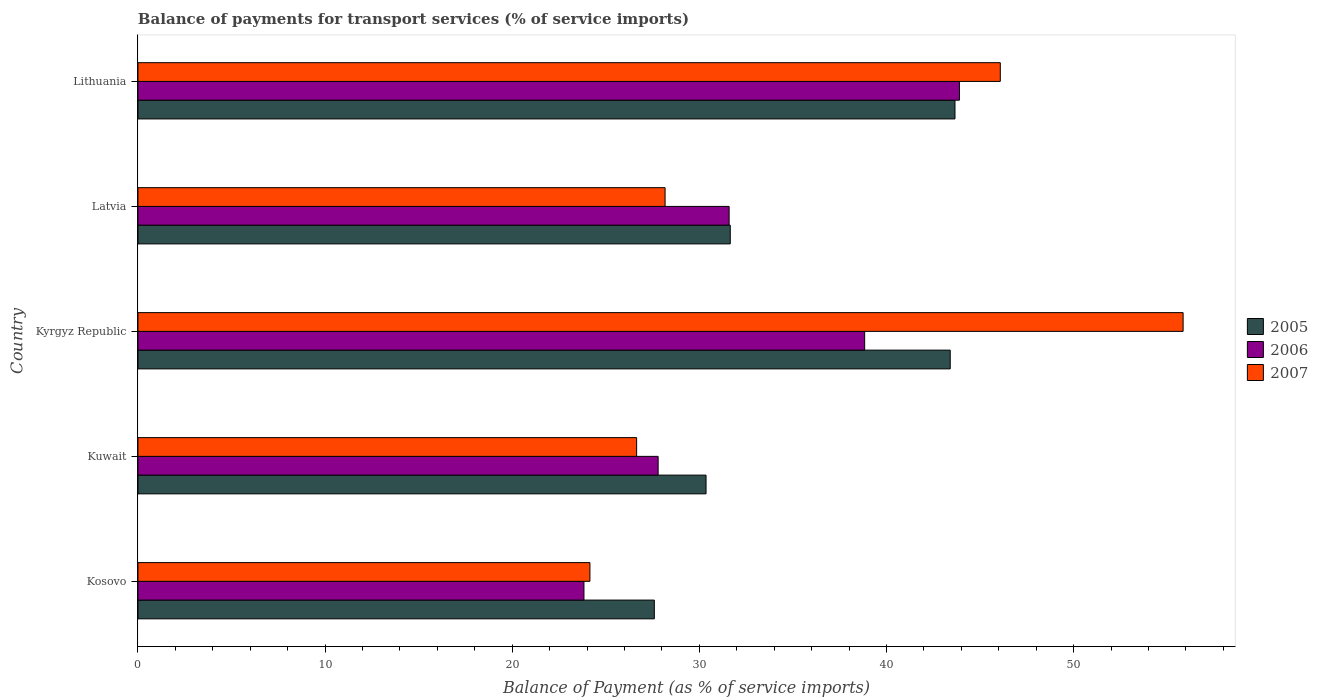How many different coloured bars are there?
Give a very brief answer. 3. How many groups of bars are there?
Keep it short and to the point. 5. How many bars are there on the 5th tick from the top?
Keep it short and to the point. 3. What is the label of the 5th group of bars from the top?
Ensure brevity in your answer.  Kosovo. What is the balance of payments for transport services in 2006 in Lithuania?
Offer a terse response. 43.9. Across all countries, what is the maximum balance of payments for transport services in 2005?
Your answer should be very brief. 43.66. Across all countries, what is the minimum balance of payments for transport services in 2007?
Your answer should be compact. 24.15. In which country was the balance of payments for transport services in 2007 maximum?
Make the answer very short. Kyrgyz Republic. In which country was the balance of payments for transport services in 2006 minimum?
Make the answer very short. Kosovo. What is the total balance of payments for transport services in 2007 in the graph?
Ensure brevity in your answer.  180.9. What is the difference between the balance of payments for transport services in 2005 in Kyrgyz Republic and that in Latvia?
Your answer should be very brief. 11.75. What is the difference between the balance of payments for transport services in 2006 in Kuwait and the balance of payments for transport services in 2007 in Lithuania?
Your answer should be very brief. -18.28. What is the average balance of payments for transport services in 2007 per country?
Provide a succinct answer. 36.18. What is the difference between the balance of payments for transport services in 2005 and balance of payments for transport services in 2006 in Kyrgyz Republic?
Your answer should be compact. 4.57. What is the ratio of the balance of payments for transport services in 2007 in Latvia to that in Lithuania?
Your answer should be compact. 0.61. Is the difference between the balance of payments for transport services in 2005 in Kuwait and Kyrgyz Republic greater than the difference between the balance of payments for transport services in 2006 in Kuwait and Kyrgyz Republic?
Ensure brevity in your answer.  No. What is the difference between the highest and the second highest balance of payments for transport services in 2005?
Provide a short and direct response. 0.25. What is the difference between the highest and the lowest balance of payments for transport services in 2007?
Ensure brevity in your answer.  31.7. What does the 1st bar from the top in Latvia represents?
Make the answer very short. 2007. How many bars are there?
Offer a very short reply. 15. Are all the bars in the graph horizontal?
Offer a terse response. Yes. Are the values on the major ticks of X-axis written in scientific E-notation?
Offer a very short reply. No. Does the graph contain grids?
Offer a terse response. No. Where does the legend appear in the graph?
Your answer should be very brief. Center right. How are the legend labels stacked?
Offer a very short reply. Vertical. What is the title of the graph?
Your answer should be very brief. Balance of payments for transport services (% of service imports). What is the label or title of the X-axis?
Give a very brief answer. Balance of Payment (as % of service imports). What is the Balance of Payment (as % of service imports) in 2005 in Kosovo?
Your answer should be compact. 27.59. What is the Balance of Payment (as % of service imports) of 2006 in Kosovo?
Ensure brevity in your answer.  23.83. What is the Balance of Payment (as % of service imports) of 2007 in Kosovo?
Offer a very short reply. 24.15. What is the Balance of Payment (as % of service imports) in 2005 in Kuwait?
Offer a very short reply. 30.36. What is the Balance of Payment (as % of service imports) in 2006 in Kuwait?
Your answer should be compact. 27.8. What is the Balance of Payment (as % of service imports) of 2007 in Kuwait?
Your answer should be very brief. 26.65. What is the Balance of Payment (as % of service imports) of 2005 in Kyrgyz Republic?
Provide a short and direct response. 43.41. What is the Balance of Payment (as % of service imports) of 2006 in Kyrgyz Republic?
Offer a very short reply. 38.83. What is the Balance of Payment (as % of service imports) in 2007 in Kyrgyz Republic?
Offer a very short reply. 55.85. What is the Balance of Payment (as % of service imports) of 2005 in Latvia?
Offer a very short reply. 31.65. What is the Balance of Payment (as % of service imports) of 2006 in Latvia?
Your response must be concise. 31.59. What is the Balance of Payment (as % of service imports) in 2007 in Latvia?
Your answer should be very brief. 28.17. What is the Balance of Payment (as % of service imports) in 2005 in Lithuania?
Make the answer very short. 43.66. What is the Balance of Payment (as % of service imports) in 2006 in Lithuania?
Your answer should be very brief. 43.9. What is the Balance of Payment (as % of service imports) of 2007 in Lithuania?
Offer a very short reply. 46.08. Across all countries, what is the maximum Balance of Payment (as % of service imports) in 2005?
Ensure brevity in your answer.  43.66. Across all countries, what is the maximum Balance of Payment (as % of service imports) in 2006?
Give a very brief answer. 43.9. Across all countries, what is the maximum Balance of Payment (as % of service imports) of 2007?
Your answer should be very brief. 55.85. Across all countries, what is the minimum Balance of Payment (as % of service imports) of 2005?
Make the answer very short. 27.59. Across all countries, what is the minimum Balance of Payment (as % of service imports) in 2006?
Offer a very short reply. 23.83. Across all countries, what is the minimum Balance of Payment (as % of service imports) in 2007?
Offer a terse response. 24.15. What is the total Balance of Payment (as % of service imports) of 2005 in the graph?
Provide a short and direct response. 176.67. What is the total Balance of Payment (as % of service imports) of 2006 in the graph?
Ensure brevity in your answer.  165.95. What is the total Balance of Payment (as % of service imports) of 2007 in the graph?
Your response must be concise. 180.9. What is the difference between the Balance of Payment (as % of service imports) in 2005 in Kosovo and that in Kuwait?
Make the answer very short. -2.76. What is the difference between the Balance of Payment (as % of service imports) in 2006 in Kosovo and that in Kuwait?
Ensure brevity in your answer.  -3.96. What is the difference between the Balance of Payment (as % of service imports) in 2007 in Kosovo and that in Kuwait?
Your answer should be compact. -2.5. What is the difference between the Balance of Payment (as % of service imports) in 2005 in Kosovo and that in Kyrgyz Republic?
Your answer should be very brief. -15.81. What is the difference between the Balance of Payment (as % of service imports) of 2006 in Kosovo and that in Kyrgyz Republic?
Offer a terse response. -15. What is the difference between the Balance of Payment (as % of service imports) in 2007 in Kosovo and that in Kyrgyz Republic?
Your answer should be very brief. -31.7. What is the difference between the Balance of Payment (as % of service imports) in 2005 in Kosovo and that in Latvia?
Give a very brief answer. -4.06. What is the difference between the Balance of Payment (as % of service imports) in 2006 in Kosovo and that in Latvia?
Your response must be concise. -7.76. What is the difference between the Balance of Payment (as % of service imports) in 2007 in Kosovo and that in Latvia?
Your answer should be very brief. -4.02. What is the difference between the Balance of Payment (as % of service imports) of 2005 in Kosovo and that in Lithuania?
Give a very brief answer. -16.07. What is the difference between the Balance of Payment (as % of service imports) of 2006 in Kosovo and that in Lithuania?
Offer a terse response. -20.07. What is the difference between the Balance of Payment (as % of service imports) in 2007 in Kosovo and that in Lithuania?
Give a very brief answer. -21.93. What is the difference between the Balance of Payment (as % of service imports) in 2005 in Kuwait and that in Kyrgyz Republic?
Your answer should be very brief. -13.05. What is the difference between the Balance of Payment (as % of service imports) of 2006 in Kuwait and that in Kyrgyz Republic?
Your answer should be compact. -11.04. What is the difference between the Balance of Payment (as % of service imports) in 2007 in Kuwait and that in Kyrgyz Republic?
Your answer should be compact. -29.2. What is the difference between the Balance of Payment (as % of service imports) of 2005 in Kuwait and that in Latvia?
Ensure brevity in your answer.  -1.29. What is the difference between the Balance of Payment (as % of service imports) of 2006 in Kuwait and that in Latvia?
Ensure brevity in your answer.  -3.79. What is the difference between the Balance of Payment (as % of service imports) of 2007 in Kuwait and that in Latvia?
Your answer should be compact. -1.52. What is the difference between the Balance of Payment (as % of service imports) in 2005 in Kuwait and that in Lithuania?
Your answer should be very brief. -13.3. What is the difference between the Balance of Payment (as % of service imports) in 2006 in Kuwait and that in Lithuania?
Ensure brevity in your answer.  -16.1. What is the difference between the Balance of Payment (as % of service imports) of 2007 in Kuwait and that in Lithuania?
Make the answer very short. -19.43. What is the difference between the Balance of Payment (as % of service imports) in 2005 in Kyrgyz Republic and that in Latvia?
Keep it short and to the point. 11.75. What is the difference between the Balance of Payment (as % of service imports) of 2006 in Kyrgyz Republic and that in Latvia?
Offer a very short reply. 7.24. What is the difference between the Balance of Payment (as % of service imports) in 2007 in Kyrgyz Republic and that in Latvia?
Make the answer very short. 27.68. What is the difference between the Balance of Payment (as % of service imports) of 2005 in Kyrgyz Republic and that in Lithuania?
Make the answer very short. -0.25. What is the difference between the Balance of Payment (as % of service imports) of 2006 in Kyrgyz Republic and that in Lithuania?
Offer a very short reply. -5.07. What is the difference between the Balance of Payment (as % of service imports) in 2007 in Kyrgyz Republic and that in Lithuania?
Your response must be concise. 9.77. What is the difference between the Balance of Payment (as % of service imports) of 2005 in Latvia and that in Lithuania?
Your answer should be very brief. -12.01. What is the difference between the Balance of Payment (as % of service imports) of 2006 in Latvia and that in Lithuania?
Provide a succinct answer. -12.31. What is the difference between the Balance of Payment (as % of service imports) in 2007 in Latvia and that in Lithuania?
Keep it short and to the point. -17.91. What is the difference between the Balance of Payment (as % of service imports) of 2005 in Kosovo and the Balance of Payment (as % of service imports) of 2006 in Kuwait?
Offer a very short reply. -0.2. What is the difference between the Balance of Payment (as % of service imports) in 2005 in Kosovo and the Balance of Payment (as % of service imports) in 2007 in Kuwait?
Your response must be concise. 0.95. What is the difference between the Balance of Payment (as % of service imports) of 2006 in Kosovo and the Balance of Payment (as % of service imports) of 2007 in Kuwait?
Your response must be concise. -2.81. What is the difference between the Balance of Payment (as % of service imports) in 2005 in Kosovo and the Balance of Payment (as % of service imports) in 2006 in Kyrgyz Republic?
Your answer should be compact. -11.24. What is the difference between the Balance of Payment (as % of service imports) of 2005 in Kosovo and the Balance of Payment (as % of service imports) of 2007 in Kyrgyz Republic?
Ensure brevity in your answer.  -28.26. What is the difference between the Balance of Payment (as % of service imports) of 2006 in Kosovo and the Balance of Payment (as % of service imports) of 2007 in Kyrgyz Republic?
Offer a terse response. -32.02. What is the difference between the Balance of Payment (as % of service imports) in 2005 in Kosovo and the Balance of Payment (as % of service imports) in 2006 in Latvia?
Your answer should be very brief. -4. What is the difference between the Balance of Payment (as % of service imports) of 2005 in Kosovo and the Balance of Payment (as % of service imports) of 2007 in Latvia?
Offer a terse response. -0.57. What is the difference between the Balance of Payment (as % of service imports) in 2006 in Kosovo and the Balance of Payment (as % of service imports) in 2007 in Latvia?
Make the answer very short. -4.33. What is the difference between the Balance of Payment (as % of service imports) of 2005 in Kosovo and the Balance of Payment (as % of service imports) of 2006 in Lithuania?
Provide a succinct answer. -16.3. What is the difference between the Balance of Payment (as % of service imports) of 2005 in Kosovo and the Balance of Payment (as % of service imports) of 2007 in Lithuania?
Offer a very short reply. -18.49. What is the difference between the Balance of Payment (as % of service imports) of 2006 in Kosovo and the Balance of Payment (as % of service imports) of 2007 in Lithuania?
Ensure brevity in your answer.  -22.25. What is the difference between the Balance of Payment (as % of service imports) of 2005 in Kuwait and the Balance of Payment (as % of service imports) of 2006 in Kyrgyz Republic?
Provide a succinct answer. -8.48. What is the difference between the Balance of Payment (as % of service imports) of 2005 in Kuwait and the Balance of Payment (as % of service imports) of 2007 in Kyrgyz Republic?
Ensure brevity in your answer.  -25.49. What is the difference between the Balance of Payment (as % of service imports) of 2006 in Kuwait and the Balance of Payment (as % of service imports) of 2007 in Kyrgyz Republic?
Provide a succinct answer. -28.05. What is the difference between the Balance of Payment (as % of service imports) of 2005 in Kuwait and the Balance of Payment (as % of service imports) of 2006 in Latvia?
Provide a succinct answer. -1.23. What is the difference between the Balance of Payment (as % of service imports) in 2005 in Kuwait and the Balance of Payment (as % of service imports) in 2007 in Latvia?
Make the answer very short. 2.19. What is the difference between the Balance of Payment (as % of service imports) in 2006 in Kuwait and the Balance of Payment (as % of service imports) in 2007 in Latvia?
Provide a short and direct response. -0.37. What is the difference between the Balance of Payment (as % of service imports) in 2005 in Kuwait and the Balance of Payment (as % of service imports) in 2006 in Lithuania?
Make the answer very short. -13.54. What is the difference between the Balance of Payment (as % of service imports) of 2005 in Kuwait and the Balance of Payment (as % of service imports) of 2007 in Lithuania?
Provide a short and direct response. -15.72. What is the difference between the Balance of Payment (as % of service imports) of 2006 in Kuwait and the Balance of Payment (as % of service imports) of 2007 in Lithuania?
Provide a succinct answer. -18.28. What is the difference between the Balance of Payment (as % of service imports) of 2005 in Kyrgyz Republic and the Balance of Payment (as % of service imports) of 2006 in Latvia?
Make the answer very short. 11.81. What is the difference between the Balance of Payment (as % of service imports) in 2005 in Kyrgyz Republic and the Balance of Payment (as % of service imports) in 2007 in Latvia?
Provide a short and direct response. 15.24. What is the difference between the Balance of Payment (as % of service imports) of 2006 in Kyrgyz Republic and the Balance of Payment (as % of service imports) of 2007 in Latvia?
Provide a succinct answer. 10.66. What is the difference between the Balance of Payment (as % of service imports) of 2005 in Kyrgyz Republic and the Balance of Payment (as % of service imports) of 2006 in Lithuania?
Provide a succinct answer. -0.49. What is the difference between the Balance of Payment (as % of service imports) of 2005 in Kyrgyz Republic and the Balance of Payment (as % of service imports) of 2007 in Lithuania?
Make the answer very short. -2.68. What is the difference between the Balance of Payment (as % of service imports) of 2006 in Kyrgyz Republic and the Balance of Payment (as % of service imports) of 2007 in Lithuania?
Give a very brief answer. -7.25. What is the difference between the Balance of Payment (as % of service imports) of 2005 in Latvia and the Balance of Payment (as % of service imports) of 2006 in Lithuania?
Provide a short and direct response. -12.25. What is the difference between the Balance of Payment (as % of service imports) of 2005 in Latvia and the Balance of Payment (as % of service imports) of 2007 in Lithuania?
Keep it short and to the point. -14.43. What is the difference between the Balance of Payment (as % of service imports) in 2006 in Latvia and the Balance of Payment (as % of service imports) in 2007 in Lithuania?
Provide a short and direct response. -14.49. What is the average Balance of Payment (as % of service imports) in 2005 per country?
Your answer should be compact. 35.33. What is the average Balance of Payment (as % of service imports) in 2006 per country?
Make the answer very short. 33.19. What is the average Balance of Payment (as % of service imports) of 2007 per country?
Provide a succinct answer. 36.18. What is the difference between the Balance of Payment (as % of service imports) in 2005 and Balance of Payment (as % of service imports) in 2006 in Kosovo?
Your response must be concise. 3.76. What is the difference between the Balance of Payment (as % of service imports) in 2005 and Balance of Payment (as % of service imports) in 2007 in Kosovo?
Your answer should be compact. 3.44. What is the difference between the Balance of Payment (as % of service imports) of 2006 and Balance of Payment (as % of service imports) of 2007 in Kosovo?
Give a very brief answer. -0.32. What is the difference between the Balance of Payment (as % of service imports) in 2005 and Balance of Payment (as % of service imports) in 2006 in Kuwait?
Give a very brief answer. 2.56. What is the difference between the Balance of Payment (as % of service imports) in 2005 and Balance of Payment (as % of service imports) in 2007 in Kuwait?
Your answer should be very brief. 3.71. What is the difference between the Balance of Payment (as % of service imports) of 2006 and Balance of Payment (as % of service imports) of 2007 in Kuwait?
Offer a very short reply. 1.15. What is the difference between the Balance of Payment (as % of service imports) of 2005 and Balance of Payment (as % of service imports) of 2006 in Kyrgyz Republic?
Your answer should be very brief. 4.57. What is the difference between the Balance of Payment (as % of service imports) in 2005 and Balance of Payment (as % of service imports) in 2007 in Kyrgyz Republic?
Provide a short and direct response. -12.44. What is the difference between the Balance of Payment (as % of service imports) in 2006 and Balance of Payment (as % of service imports) in 2007 in Kyrgyz Republic?
Make the answer very short. -17.02. What is the difference between the Balance of Payment (as % of service imports) in 2005 and Balance of Payment (as % of service imports) in 2006 in Latvia?
Your answer should be very brief. 0.06. What is the difference between the Balance of Payment (as % of service imports) of 2005 and Balance of Payment (as % of service imports) of 2007 in Latvia?
Keep it short and to the point. 3.48. What is the difference between the Balance of Payment (as % of service imports) in 2006 and Balance of Payment (as % of service imports) in 2007 in Latvia?
Give a very brief answer. 3.42. What is the difference between the Balance of Payment (as % of service imports) in 2005 and Balance of Payment (as % of service imports) in 2006 in Lithuania?
Your answer should be compact. -0.24. What is the difference between the Balance of Payment (as % of service imports) in 2005 and Balance of Payment (as % of service imports) in 2007 in Lithuania?
Your answer should be very brief. -2.42. What is the difference between the Balance of Payment (as % of service imports) in 2006 and Balance of Payment (as % of service imports) in 2007 in Lithuania?
Your response must be concise. -2.18. What is the ratio of the Balance of Payment (as % of service imports) in 2005 in Kosovo to that in Kuwait?
Keep it short and to the point. 0.91. What is the ratio of the Balance of Payment (as % of service imports) in 2006 in Kosovo to that in Kuwait?
Give a very brief answer. 0.86. What is the ratio of the Balance of Payment (as % of service imports) in 2007 in Kosovo to that in Kuwait?
Offer a very short reply. 0.91. What is the ratio of the Balance of Payment (as % of service imports) in 2005 in Kosovo to that in Kyrgyz Republic?
Offer a very short reply. 0.64. What is the ratio of the Balance of Payment (as % of service imports) of 2006 in Kosovo to that in Kyrgyz Republic?
Make the answer very short. 0.61. What is the ratio of the Balance of Payment (as % of service imports) of 2007 in Kosovo to that in Kyrgyz Republic?
Your response must be concise. 0.43. What is the ratio of the Balance of Payment (as % of service imports) in 2005 in Kosovo to that in Latvia?
Give a very brief answer. 0.87. What is the ratio of the Balance of Payment (as % of service imports) of 2006 in Kosovo to that in Latvia?
Your answer should be very brief. 0.75. What is the ratio of the Balance of Payment (as % of service imports) of 2007 in Kosovo to that in Latvia?
Your answer should be very brief. 0.86. What is the ratio of the Balance of Payment (as % of service imports) in 2005 in Kosovo to that in Lithuania?
Your response must be concise. 0.63. What is the ratio of the Balance of Payment (as % of service imports) in 2006 in Kosovo to that in Lithuania?
Your response must be concise. 0.54. What is the ratio of the Balance of Payment (as % of service imports) of 2007 in Kosovo to that in Lithuania?
Make the answer very short. 0.52. What is the ratio of the Balance of Payment (as % of service imports) in 2005 in Kuwait to that in Kyrgyz Republic?
Your response must be concise. 0.7. What is the ratio of the Balance of Payment (as % of service imports) of 2006 in Kuwait to that in Kyrgyz Republic?
Your answer should be very brief. 0.72. What is the ratio of the Balance of Payment (as % of service imports) in 2007 in Kuwait to that in Kyrgyz Republic?
Your response must be concise. 0.48. What is the ratio of the Balance of Payment (as % of service imports) of 2005 in Kuwait to that in Latvia?
Give a very brief answer. 0.96. What is the ratio of the Balance of Payment (as % of service imports) in 2006 in Kuwait to that in Latvia?
Your response must be concise. 0.88. What is the ratio of the Balance of Payment (as % of service imports) of 2007 in Kuwait to that in Latvia?
Your response must be concise. 0.95. What is the ratio of the Balance of Payment (as % of service imports) of 2005 in Kuwait to that in Lithuania?
Provide a short and direct response. 0.7. What is the ratio of the Balance of Payment (as % of service imports) of 2006 in Kuwait to that in Lithuania?
Provide a succinct answer. 0.63. What is the ratio of the Balance of Payment (as % of service imports) in 2007 in Kuwait to that in Lithuania?
Make the answer very short. 0.58. What is the ratio of the Balance of Payment (as % of service imports) in 2005 in Kyrgyz Republic to that in Latvia?
Keep it short and to the point. 1.37. What is the ratio of the Balance of Payment (as % of service imports) in 2006 in Kyrgyz Republic to that in Latvia?
Ensure brevity in your answer.  1.23. What is the ratio of the Balance of Payment (as % of service imports) of 2007 in Kyrgyz Republic to that in Latvia?
Your answer should be very brief. 1.98. What is the ratio of the Balance of Payment (as % of service imports) of 2006 in Kyrgyz Republic to that in Lithuania?
Offer a terse response. 0.88. What is the ratio of the Balance of Payment (as % of service imports) of 2007 in Kyrgyz Republic to that in Lithuania?
Provide a short and direct response. 1.21. What is the ratio of the Balance of Payment (as % of service imports) of 2005 in Latvia to that in Lithuania?
Your answer should be very brief. 0.72. What is the ratio of the Balance of Payment (as % of service imports) of 2006 in Latvia to that in Lithuania?
Ensure brevity in your answer.  0.72. What is the ratio of the Balance of Payment (as % of service imports) of 2007 in Latvia to that in Lithuania?
Provide a short and direct response. 0.61. What is the difference between the highest and the second highest Balance of Payment (as % of service imports) in 2005?
Your response must be concise. 0.25. What is the difference between the highest and the second highest Balance of Payment (as % of service imports) in 2006?
Ensure brevity in your answer.  5.07. What is the difference between the highest and the second highest Balance of Payment (as % of service imports) of 2007?
Make the answer very short. 9.77. What is the difference between the highest and the lowest Balance of Payment (as % of service imports) in 2005?
Give a very brief answer. 16.07. What is the difference between the highest and the lowest Balance of Payment (as % of service imports) in 2006?
Offer a very short reply. 20.07. What is the difference between the highest and the lowest Balance of Payment (as % of service imports) in 2007?
Your answer should be compact. 31.7. 